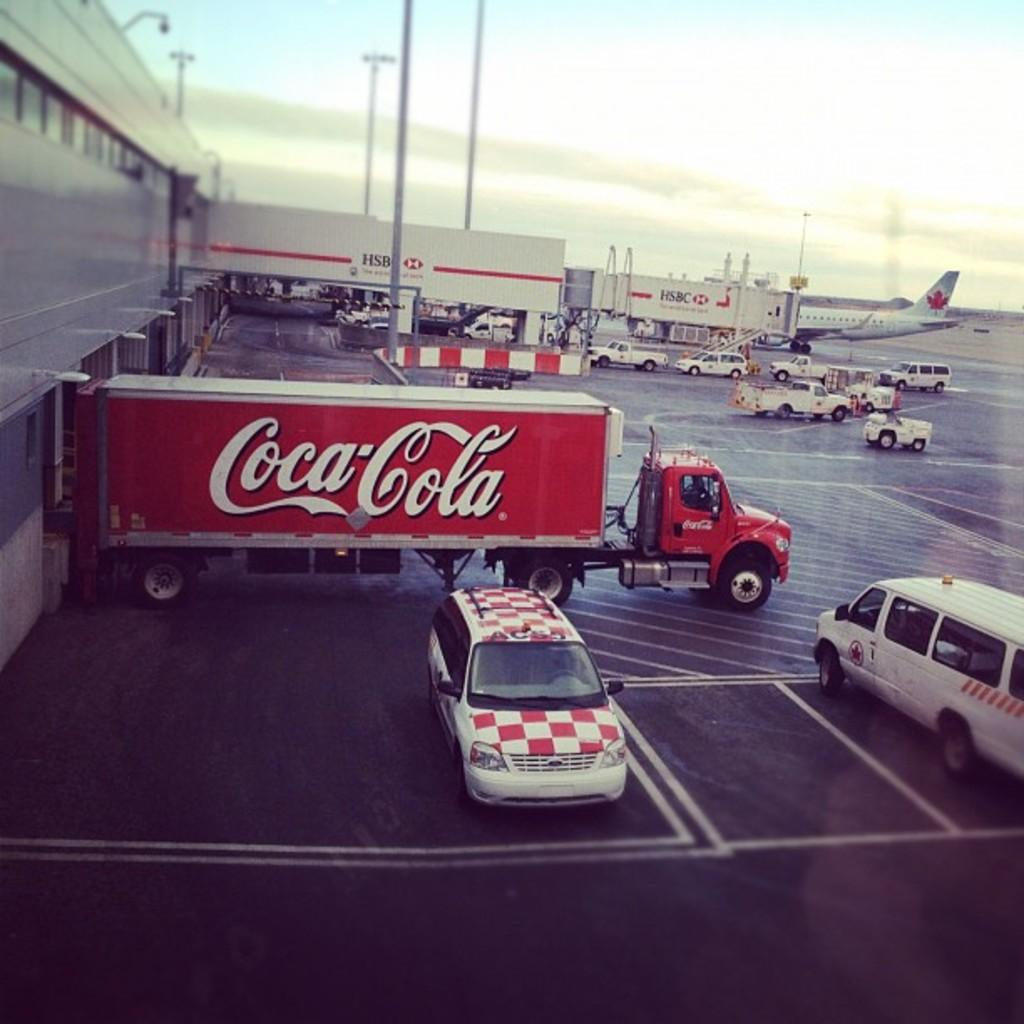<image>
Render a clear and concise summary of the photo. Coca cola truck and vans parked beside a airplane 